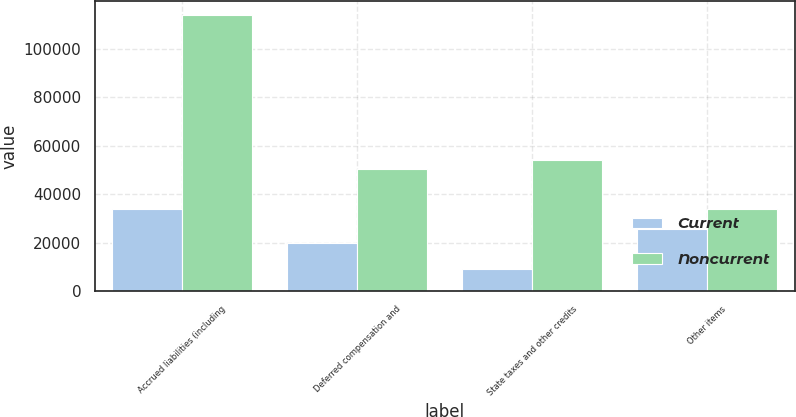Convert chart to OTSL. <chart><loc_0><loc_0><loc_500><loc_500><stacked_bar_chart><ecel><fcel>Accrued liabilities (including<fcel>Deferred compensation and<fcel>State taxes and other credits<fcel>Other items<nl><fcel>Current<fcel>33937<fcel>19769<fcel>9244<fcel>25671<nl><fcel>Noncurrent<fcel>113845<fcel>50500<fcel>54178<fcel>33937<nl></chart> 